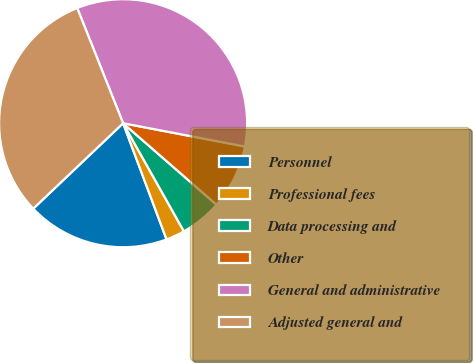<chart> <loc_0><loc_0><loc_500><loc_500><pie_chart><fcel>Personnel<fcel>Professional fees<fcel>Data processing and<fcel>Other<fcel>General and administrative<fcel>Adjusted general and<nl><fcel>18.6%<fcel>2.46%<fcel>5.43%<fcel>8.41%<fcel>34.04%<fcel>31.06%<nl></chart> 